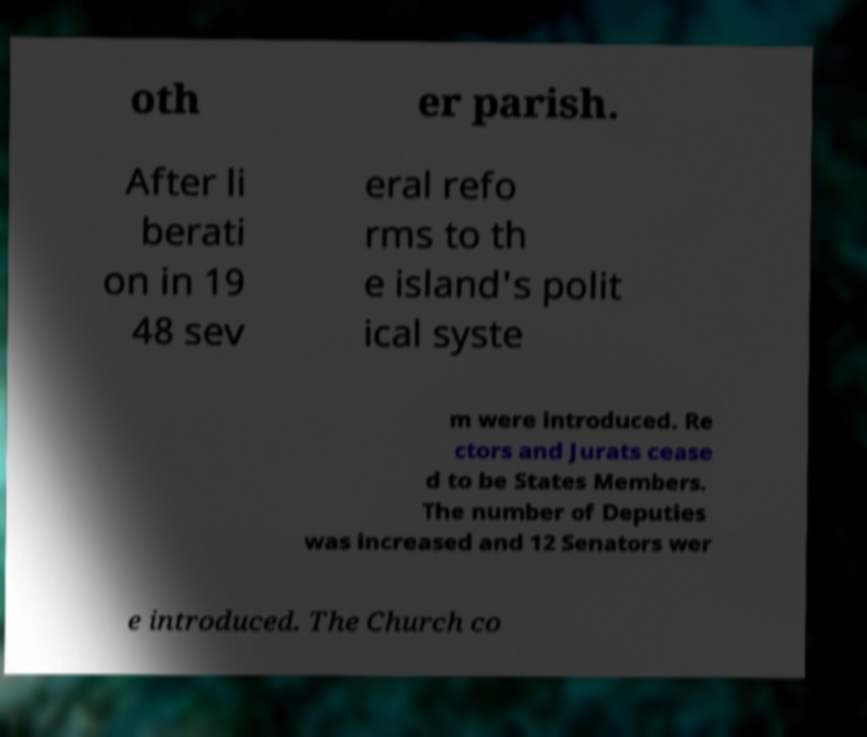Could you assist in decoding the text presented in this image and type it out clearly? oth er parish. After li berati on in 19 48 sev eral refo rms to th e island's polit ical syste m were introduced. Re ctors and Jurats cease d to be States Members. The number of Deputies was increased and 12 Senators wer e introduced. The Church co 